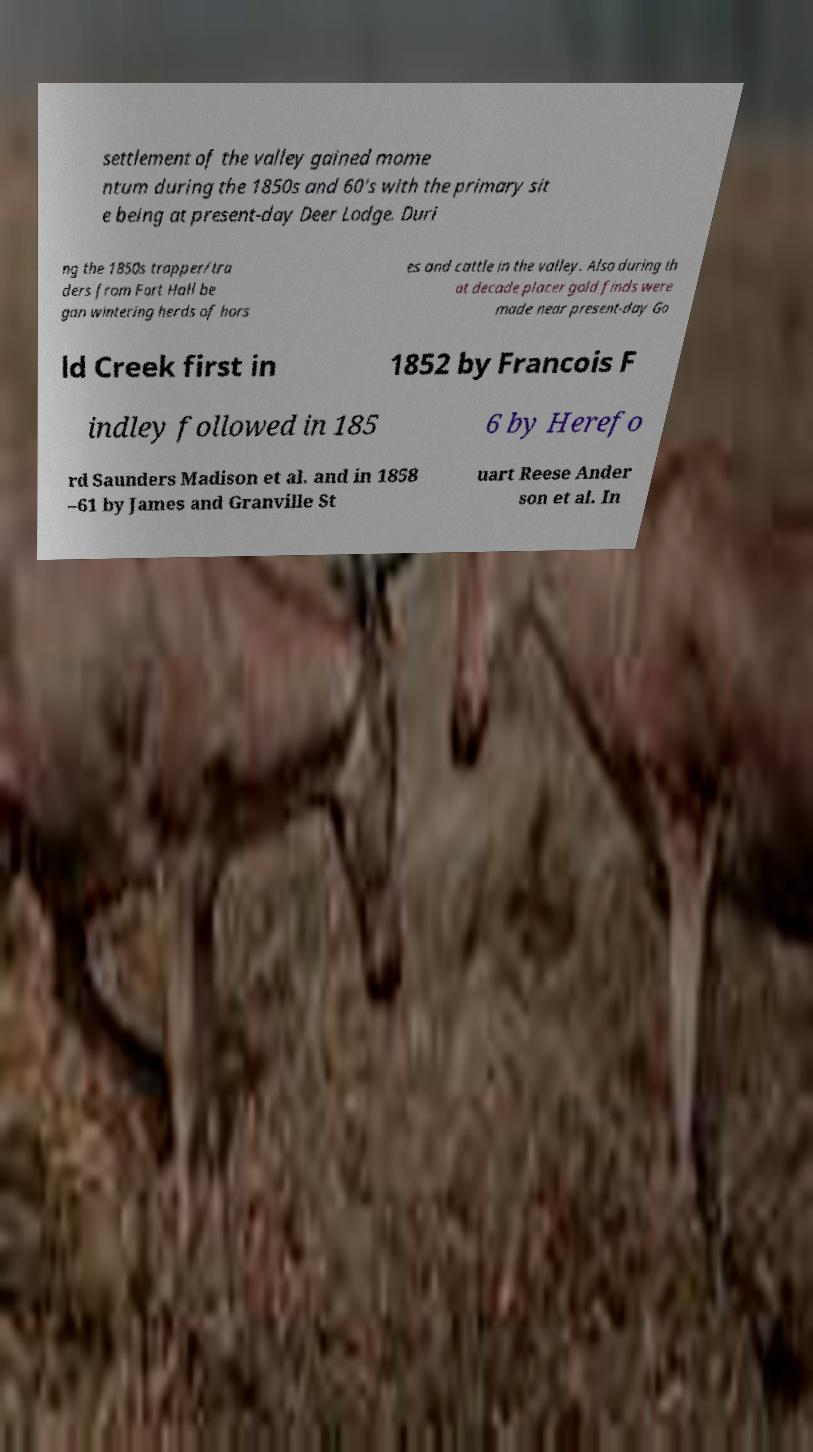Please identify and transcribe the text found in this image. settlement of the valley gained mome ntum during the 1850s and 60's with the primary sit e being at present-day Deer Lodge. Duri ng the 1850s trapper/tra ders from Fort Hall be gan wintering herds of hors es and cattle in the valley. Also during th at decade placer gold finds were made near present-day Go ld Creek first in 1852 by Francois F indley followed in 185 6 by Herefo rd Saunders Madison et al. and in 1858 –61 by James and Granville St uart Reese Ander son et al. In 